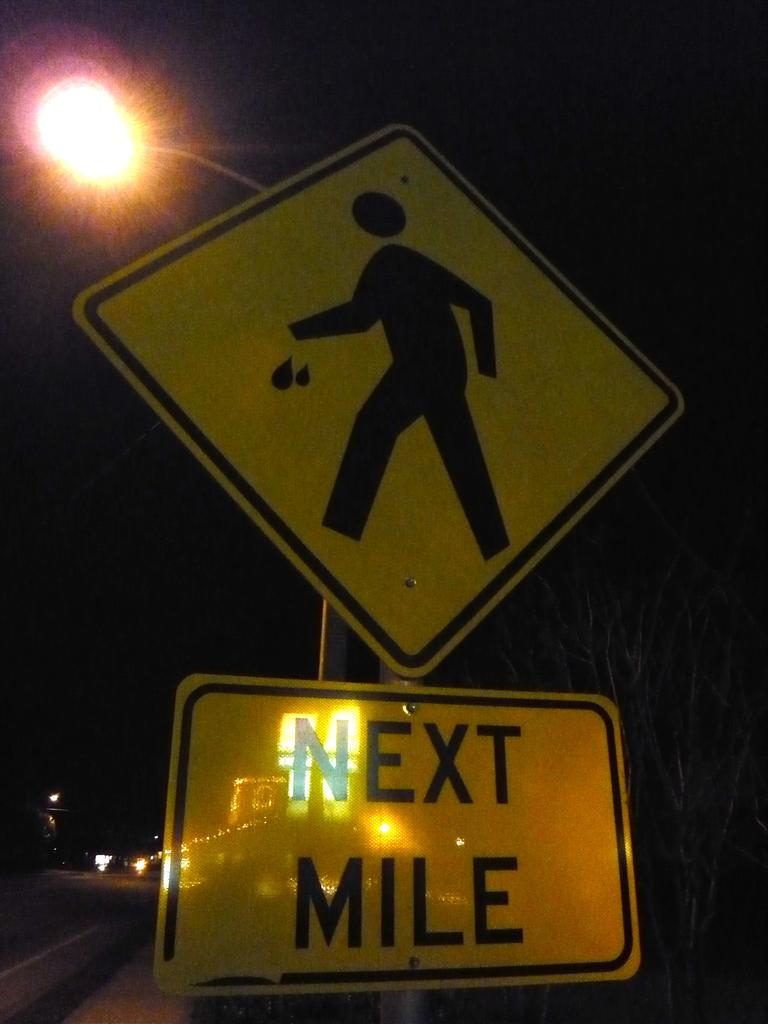What is the color of the caution board in the image? The caution board in the image is yellow. What message is displayed on the caution board? The text "Next mile" is written on the board. What type of cap is the person wearing in the image? There is no person present in the image, and therefore no cap can be observed. What is the profit margin of the company that produced the caution board in the image? There is no information about the company or profit margin in the image. 